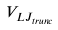<formula> <loc_0><loc_0><loc_500><loc_500>V _ { L J _ { t r u n c } }</formula> 